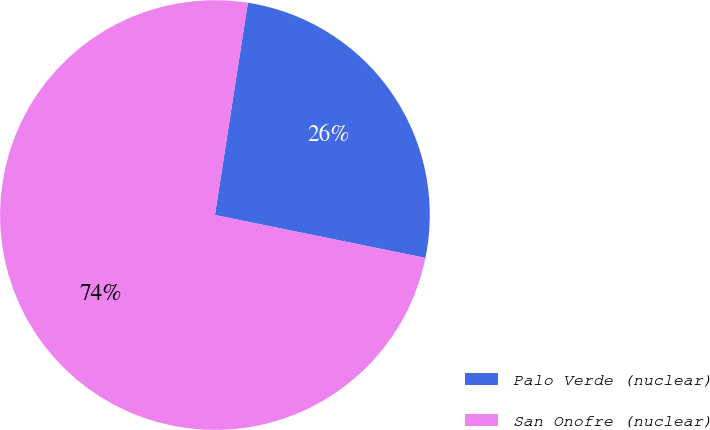<chart> <loc_0><loc_0><loc_500><loc_500><pie_chart><fcel>Palo Verde (nuclear)<fcel>San Onofre (nuclear)<nl><fcel>25.75%<fcel>74.25%<nl></chart> 